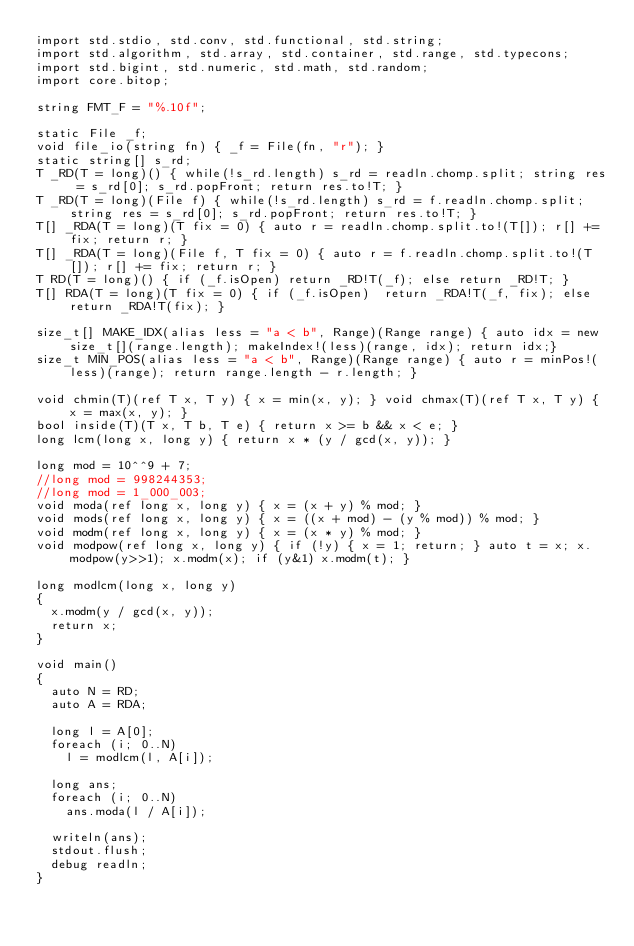Convert code to text. <code><loc_0><loc_0><loc_500><loc_500><_D_>import std.stdio, std.conv, std.functional, std.string;
import std.algorithm, std.array, std.container, std.range, std.typecons;
import std.bigint, std.numeric, std.math, std.random;
import core.bitop;

string FMT_F = "%.10f";

static File _f;
void file_io(string fn) { _f = File(fn, "r"); }
static string[] s_rd;
T _RD(T = long)() { while(!s_rd.length) s_rd = readln.chomp.split; string res = s_rd[0]; s_rd.popFront; return res.to!T; }
T _RD(T = long)(File f) { while(!s_rd.length) s_rd = f.readln.chomp.split; string res = s_rd[0]; s_rd.popFront; return res.to!T; }
T[] _RDA(T = long)(T fix = 0) { auto r = readln.chomp.split.to!(T[]); r[] += fix; return r; }
T[] _RDA(T = long)(File f, T fix = 0) { auto r = f.readln.chomp.split.to!(T[]); r[] += fix; return r; }
T RD(T = long)() { if (_f.isOpen) return _RD!T(_f); else return _RD!T; }
T[] RDA(T = long)(T fix = 0) { if (_f.isOpen)  return _RDA!T(_f, fix); else return _RDA!T(fix); }

size_t[] MAKE_IDX(alias less = "a < b", Range)(Range range) { auto idx = new size_t[](range.length); makeIndex!(less)(range, idx); return idx;}
size_t MIN_POS(alias less = "a < b", Range)(Range range) { auto r = minPos!(less)(range); return range.length - r.length; }

void chmin(T)(ref T x, T y) { x = min(x, y); } void chmax(T)(ref T x, T y) { x = max(x, y); }
bool inside(T)(T x, T b, T e) { return x >= b && x < e; }
long lcm(long x, long y) { return x * (y / gcd(x, y)); }

long mod = 10^^9 + 7;
//long mod = 998244353;
//long mod = 1_000_003;
void moda(ref long x, long y) { x = (x + y) % mod; }
void mods(ref long x, long y) { x = ((x + mod) - (y % mod)) % mod; }
void modm(ref long x, long y) { x = (x * y) % mod; }
void modpow(ref long x, long y) { if (!y) { x = 1; return; } auto t = x; x.modpow(y>>1); x.modm(x); if (y&1) x.modm(t); }

long modlcm(long x, long y)
{
	x.modm(y / gcd(x, y));
	return x;
}

void main()
{
	auto N = RD;
	auto A = RDA;

	long l = A[0];
	foreach (i; 0..N)
		l = modlcm(l, A[i]);

	long ans;
	foreach (i; 0..N)
		ans.moda(l / A[i]);

	writeln(ans);
	stdout.flush;
	debug readln;
}
</code> 